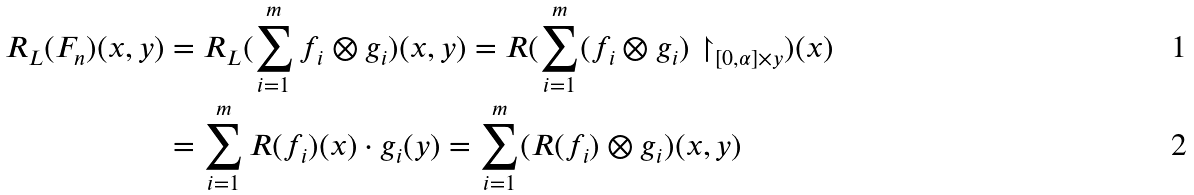<formula> <loc_0><loc_0><loc_500><loc_500>R _ { L } ( F _ { n } ) ( x , y ) & = R _ { L } ( \sum _ { i = 1 } ^ { m } f _ { i } \otimes g _ { i } ) ( x , y ) = R ( \sum _ { i = 1 } ^ { m } ( f _ { i } \otimes g _ { i } ) \restriction _ { [ 0 , \alpha ] \times { y } } ) ( x ) \\ & = \sum _ { i = 1 } ^ { m } R ( f _ { i } ) ( x ) \cdot g _ { i } ( y ) = \sum _ { i = 1 } ^ { m } ( R ( f _ { i } ) \otimes g _ { i } ) ( x , y )</formula> 